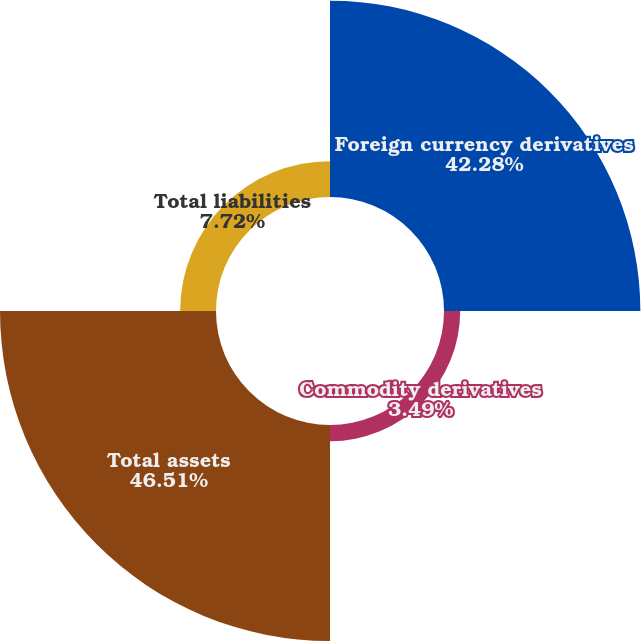Convert chart. <chart><loc_0><loc_0><loc_500><loc_500><pie_chart><fcel>Foreign currency derivatives<fcel>Commodity derivatives<fcel>Total assets<fcel>Total liabilities<nl><fcel>42.28%<fcel>3.49%<fcel>46.51%<fcel>7.72%<nl></chart> 